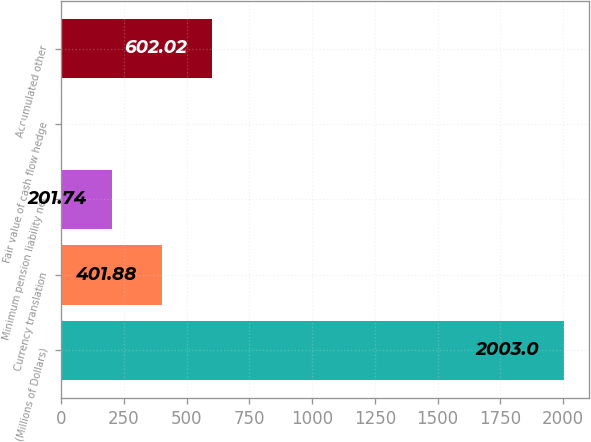Convert chart. <chart><loc_0><loc_0><loc_500><loc_500><bar_chart><fcel>(Millions of Dollars)<fcel>Currency translation<fcel>Minimum pension liability net<fcel>Fair value of cash flow hedge<fcel>Accumulated other<nl><fcel>2003<fcel>401.88<fcel>201.74<fcel>1.6<fcel>602.02<nl></chart> 